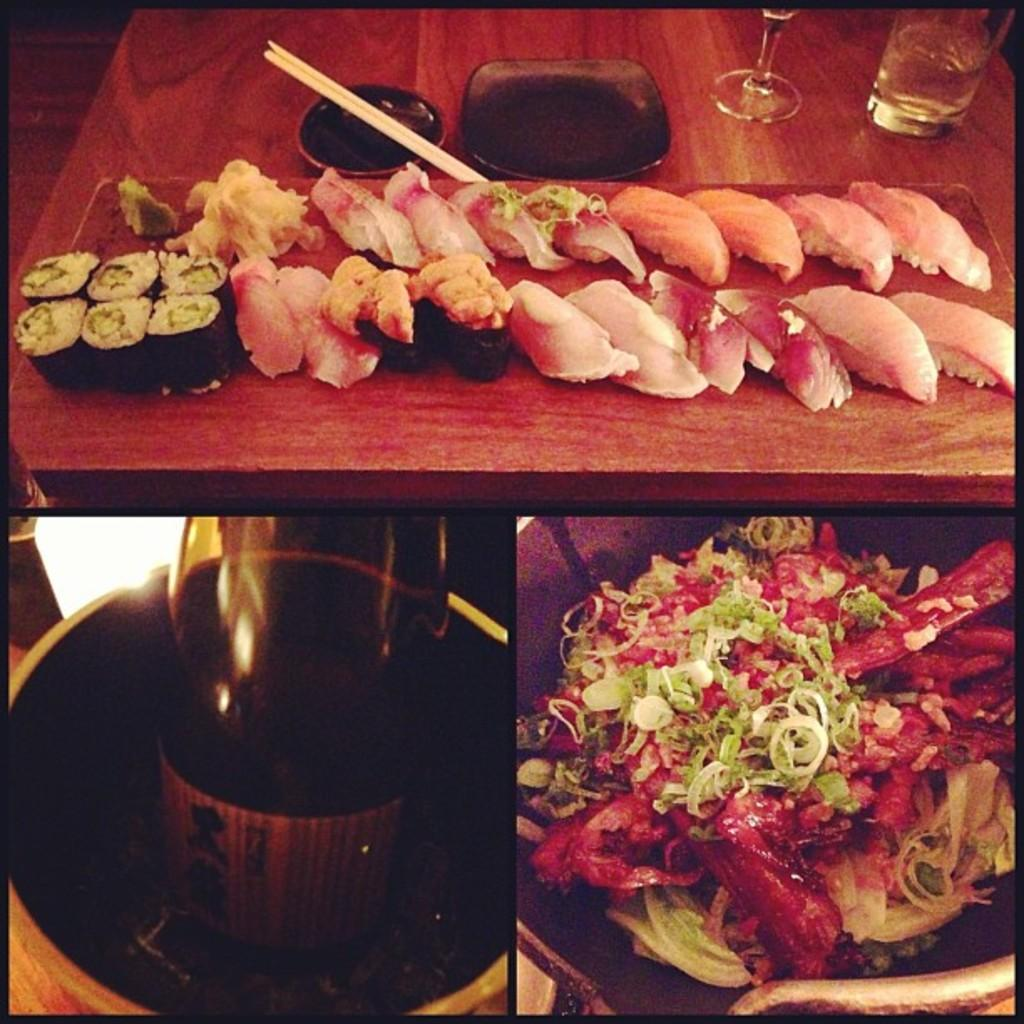What types of items are included in the collage image? The collage image contains a top and right image with food, and a left bottom image consisting of a bottle. Can you describe the top image within the collage? The top image within the collage includes chopsticks, a glass, and a plate. How many mice can be seen eating the food in the collage image? There are no mice present in the collage image. What type of leaf is used as a decoration in the collage image? There is no leaf present in the collage image. 